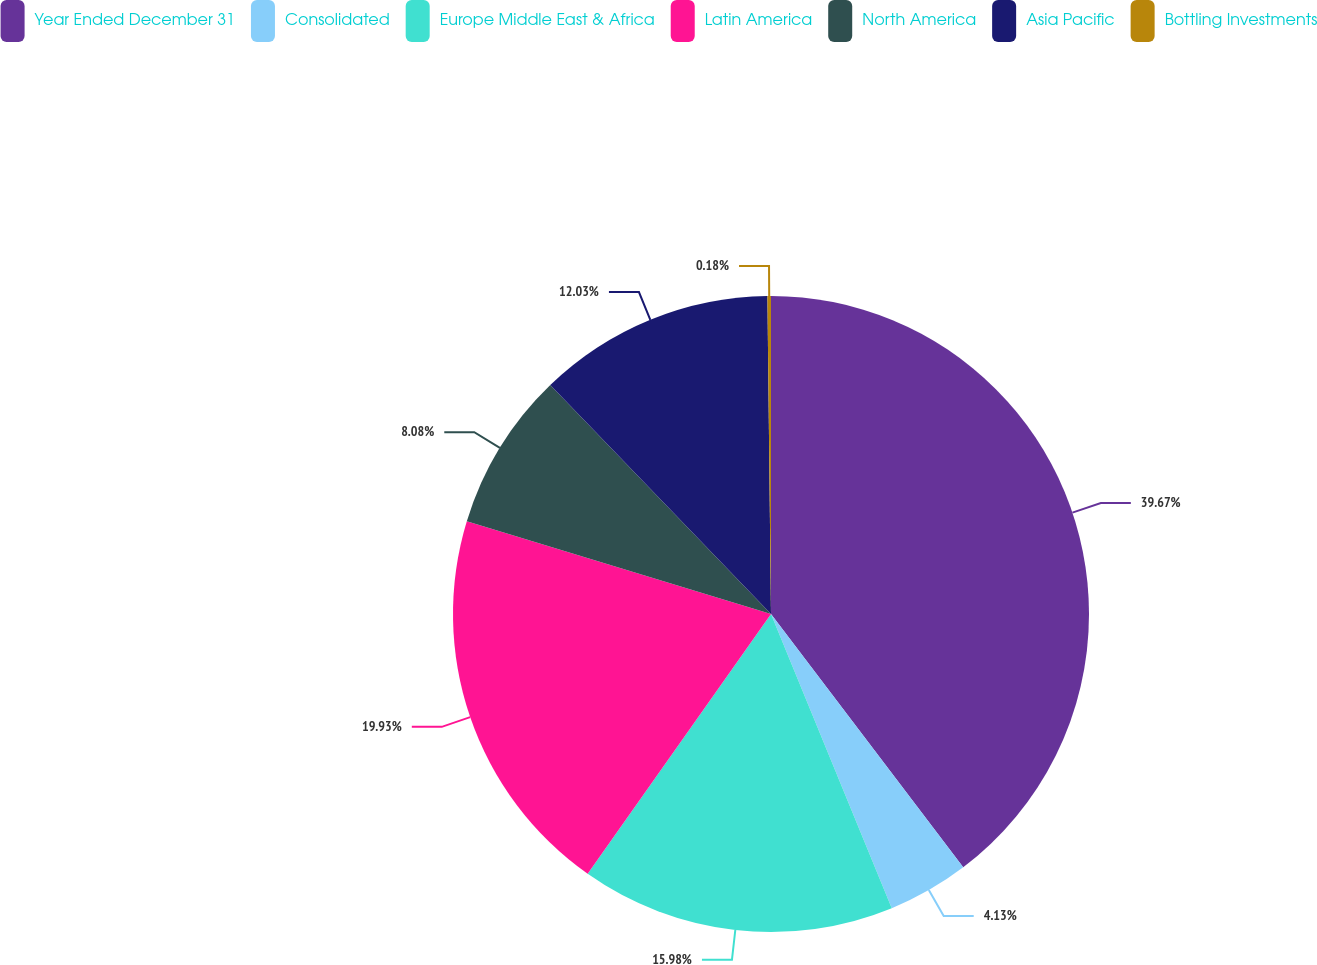Convert chart to OTSL. <chart><loc_0><loc_0><loc_500><loc_500><pie_chart><fcel>Year Ended December 31<fcel>Consolidated<fcel>Europe Middle East & Africa<fcel>Latin America<fcel>North America<fcel>Asia Pacific<fcel>Bottling Investments<nl><fcel>39.67%<fcel>4.13%<fcel>15.98%<fcel>19.93%<fcel>8.08%<fcel>12.03%<fcel>0.18%<nl></chart> 